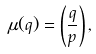Convert formula to latex. <formula><loc_0><loc_0><loc_500><loc_500>\mu ( q ) = \left ( \frac { q } { p } \right ) ,</formula> 